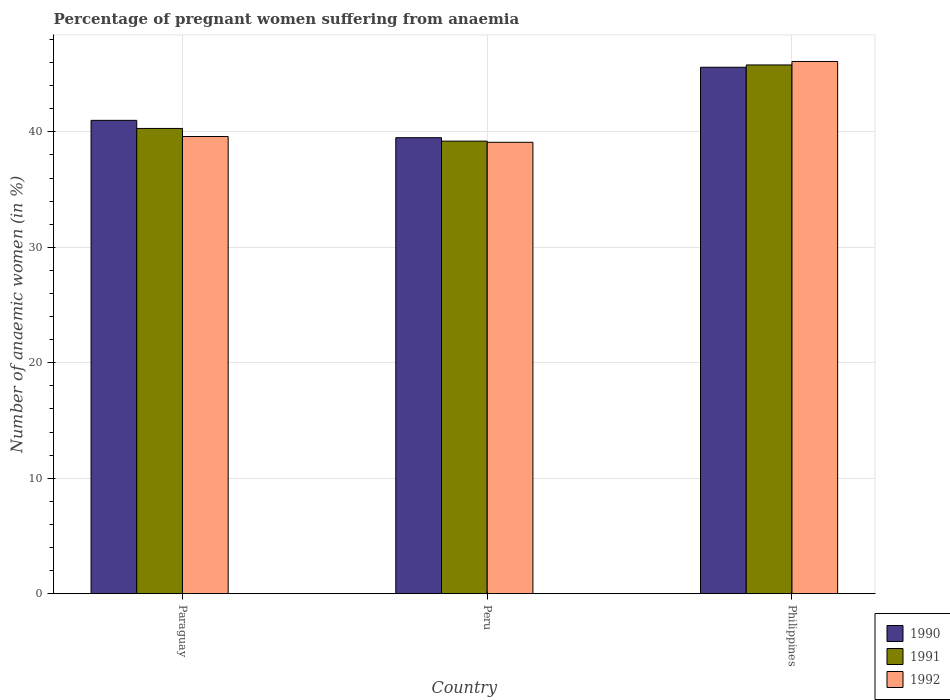How many different coloured bars are there?
Make the answer very short. 3. Are the number of bars per tick equal to the number of legend labels?
Your answer should be very brief. Yes. In how many cases, is the number of bars for a given country not equal to the number of legend labels?
Make the answer very short. 0. What is the number of anaemic women in 1992 in Peru?
Keep it short and to the point. 39.1. Across all countries, what is the maximum number of anaemic women in 1991?
Give a very brief answer. 45.8. Across all countries, what is the minimum number of anaemic women in 1992?
Provide a short and direct response. 39.1. What is the total number of anaemic women in 1991 in the graph?
Make the answer very short. 125.3. What is the difference between the number of anaemic women in 1991 in Paraguay and that in Peru?
Make the answer very short. 1.1. What is the difference between the number of anaemic women in 1990 in Peru and the number of anaemic women in 1992 in Philippines?
Give a very brief answer. -6.6. What is the average number of anaemic women in 1990 per country?
Your answer should be compact. 42.03. What is the difference between the number of anaemic women of/in 1992 and number of anaemic women of/in 1990 in Peru?
Keep it short and to the point. -0.4. What is the ratio of the number of anaemic women in 1990 in Paraguay to that in Philippines?
Offer a very short reply. 0.9. What is the difference between the highest and the second highest number of anaemic women in 1990?
Provide a succinct answer. -4.6. What is the difference between the highest and the lowest number of anaemic women in 1990?
Your response must be concise. 6.1. In how many countries, is the number of anaemic women in 1990 greater than the average number of anaemic women in 1990 taken over all countries?
Give a very brief answer. 1. Is the sum of the number of anaemic women in 1992 in Paraguay and Philippines greater than the maximum number of anaemic women in 1990 across all countries?
Your response must be concise. Yes. What does the 2nd bar from the left in Philippines represents?
Give a very brief answer. 1991. How many bars are there?
Offer a terse response. 9. Are all the bars in the graph horizontal?
Offer a very short reply. No. What is the difference between two consecutive major ticks on the Y-axis?
Ensure brevity in your answer.  10. Does the graph contain any zero values?
Your answer should be compact. No. Does the graph contain grids?
Your answer should be very brief. Yes. How many legend labels are there?
Offer a terse response. 3. What is the title of the graph?
Your answer should be compact. Percentage of pregnant women suffering from anaemia. Does "1999" appear as one of the legend labels in the graph?
Provide a short and direct response. No. What is the label or title of the X-axis?
Offer a very short reply. Country. What is the label or title of the Y-axis?
Offer a terse response. Number of anaemic women (in %). What is the Number of anaemic women (in %) of 1991 in Paraguay?
Make the answer very short. 40.3. What is the Number of anaemic women (in %) in 1992 in Paraguay?
Ensure brevity in your answer.  39.6. What is the Number of anaemic women (in %) in 1990 in Peru?
Make the answer very short. 39.5. What is the Number of anaemic women (in %) in 1991 in Peru?
Your response must be concise. 39.2. What is the Number of anaemic women (in %) in 1992 in Peru?
Your answer should be compact. 39.1. What is the Number of anaemic women (in %) of 1990 in Philippines?
Offer a very short reply. 45.6. What is the Number of anaemic women (in %) of 1991 in Philippines?
Offer a very short reply. 45.8. What is the Number of anaemic women (in %) of 1992 in Philippines?
Offer a very short reply. 46.1. Across all countries, what is the maximum Number of anaemic women (in %) of 1990?
Ensure brevity in your answer.  45.6. Across all countries, what is the maximum Number of anaemic women (in %) of 1991?
Provide a short and direct response. 45.8. Across all countries, what is the maximum Number of anaemic women (in %) of 1992?
Keep it short and to the point. 46.1. Across all countries, what is the minimum Number of anaemic women (in %) of 1990?
Your answer should be very brief. 39.5. Across all countries, what is the minimum Number of anaemic women (in %) of 1991?
Offer a terse response. 39.2. Across all countries, what is the minimum Number of anaemic women (in %) in 1992?
Make the answer very short. 39.1. What is the total Number of anaemic women (in %) of 1990 in the graph?
Your answer should be very brief. 126.1. What is the total Number of anaemic women (in %) of 1991 in the graph?
Ensure brevity in your answer.  125.3. What is the total Number of anaemic women (in %) in 1992 in the graph?
Your response must be concise. 124.8. What is the difference between the Number of anaemic women (in %) of 1991 in Paraguay and that in Philippines?
Your answer should be compact. -5.5. What is the difference between the Number of anaemic women (in %) in 1992 in Peru and that in Philippines?
Make the answer very short. -7. What is the difference between the Number of anaemic women (in %) of 1990 in Paraguay and the Number of anaemic women (in %) of 1991 in Peru?
Provide a short and direct response. 1.8. What is the difference between the Number of anaemic women (in %) in 1991 in Paraguay and the Number of anaemic women (in %) in 1992 in Peru?
Your answer should be compact. 1.2. What is the difference between the Number of anaemic women (in %) of 1990 in Paraguay and the Number of anaemic women (in %) of 1991 in Philippines?
Provide a succinct answer. -4.8. What is the difference between the Number of anaemic women (in %) in 1990 in Paraguay and the Number of anaemic women (in %) in 1992 in Philippines?
Offer a terse response. -5.1. What is the average Number of anaemic women (in %) of 1990 per country?
Your answer should be compact. 42.03. What is the average Number of anaemic women (in %) in 1991 per country?
Offer a very short reply. 41.77. What is the average Number of anaemic women (in %) in 1992 per country?
Your answer should be compact. 41.6. What is the difference between the Number of anaemic women (in %) in 1990 and Number of anaemic women (in %) in 1991 in Paraguay?
Provide a succinct answer. 0.7. What is the difference between the Number of anaemic women (in %) in 1990 and Number of anaemic women (in %) in 1992 in Paraguay?
Make the answer very short. 1.4. What is the difference between the Number of anaemic women (in %) of 1991 and Number of anaemic women (in %) of 1992 in Paraguay?
Make the answer very short. 0.7. What is the difference between the Number of anaemic women (in %) in 1990 and Number of anaemic women (in %) in 1991 in Peru?
Your answer should be compact. 0.3. What is the difference between the Number of anaemic women (in %) of 1990 and Number of anaemic women (in %) of 1992 in Peru?
Your response must be concise. 0.4. What is the difference between the Number of anaemic women (in %) in 1991 and Number of anaemic women (in %) in 1992 in Peru?
Keep it short and to the point. 0.1. What is the difference between the Number of anaemic women (in %) of 1990 and Number of anaemic women (in %) of 1991 in Philippines?
Your response must be concise. -0.2. What is the ratio of the Number of anaemic women (in %) in 1990 in Paraguay to that in Peru?
Your answer should be very brief. 1.04. What is the ratio of the Number of anaemic women (in %) in 1991 in Paraguay to that in Peru?
Offer a terse response. 1.03. What is the ratio of the Number of anaemic women (in %) in 1992 in Paraguay to that in Peru?
Provide a succinct answer. 1.01. What is the ratio of the Number of anaemic women (in %) in 1990 in Paraguay to that in Philippines?
Keep it short and to the point. 0.9. What is the ratio of the Number of anaemic women (in %) of 1991 in Paraguay to that in Philippines?
Your response must be concise. 0.88. What is the ratio of the Number of anaemic women (in %) of 1992 in Paraguay to that in Philippines?
Offer a terse response. 0.86. What is the ratio of the Number of anaemic women (in %) in 1990 in Peru to that in Philippines?
Provide a short and direct response. 0.87. What is the ratio of the Number of anaemic women (in %) of 1991 in Peru to that in Philippines?
Your response must be concise. 0.86. What is the ratio of the Number of anaemic women (in %) in 1992 in Peru to that in Philippines?
Offer a very short reply. 0.85. What is the difference between the highest and the second highest Number of anaemic women (in %) in 1990?
Offer a very short reply. 4.6. What is the difference between the highest and the second highest Number of anaemic women (in %) in 1991?
Your answer should be very brief. 5.5. What is the difference between the highest and the second highest Number of anaemic women (in %) of 1992?
Your answer should be compact. 6.5. What is the difference between the highest and the lowest Number of anaemic women (in %) of 1990?
Offer a very short reply. 6.1. What is the difference between the highest and the lowest Number of anaemic women (in %) of 1992?
Ensure brevity in your answer.  7. 